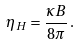Convert formula to latex. <formula><loc_0><loc_0><loc_500><loc_500>\eta _ { H } = \frac { \kappa B } { 8 \pi } \, .</formula> 